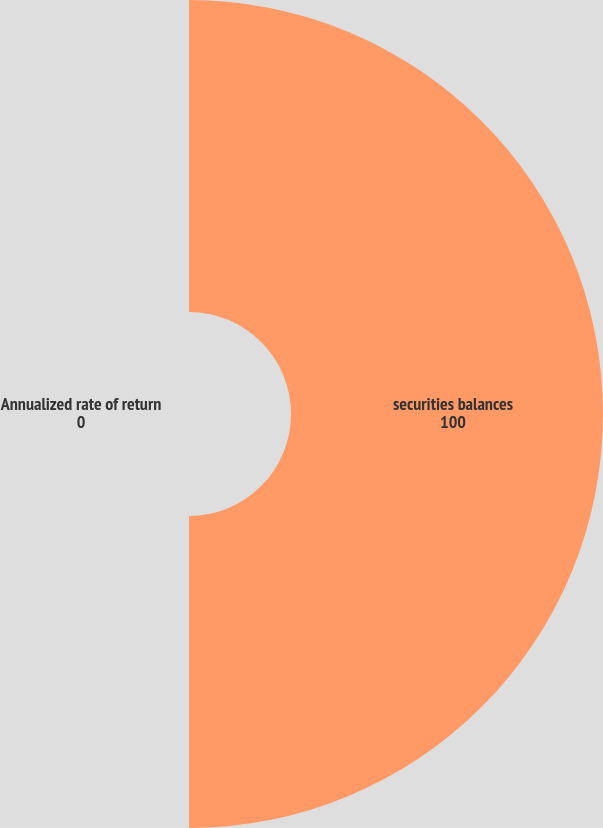Convert chart to OTSL. <chart><loc_0><loc_0><loc_500><loc_500><pie_chart><fcel>securities balances<fcel>Annualized rate of return<nl><fcel>100.0%<fcel>0.0%<nl></chart> 